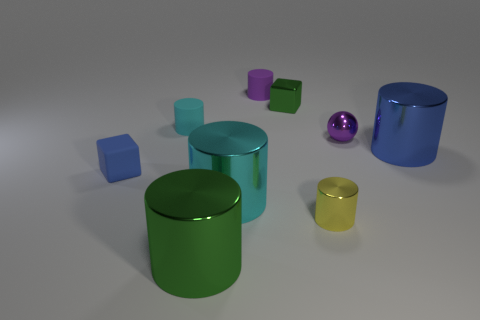The big metallic thing that is the same color as the tiny rubber block is what shape?
Provide a short and direct response. Cylinder. Is there a cylinder of the same color as the sphere?
Provide a succinct answer. Yes. What is the size of the shiny object that is the same color as the shiny block?
Give a very brief answer. Large. How many other things are the same color as the small matte block?
Make the answer very short. 1. The cyan metallic cylinder is what size?
Give a very brief answer. Large. Are there more metal things on the right side of the tiny metal ball than small green metal cubes in front of the large cyan cylinder?
Offer a terse response. Yes. What number of tiny cylinders are in front of the tiny block that is to the left of the green metal cylinder?
Make the answer very short. 1. There is a small green shiny thing that is behind the large cyan metal thing; is its shape the same as the blue rubber thing?
Your answer should be very brief. Yes. There is a green object that is the same shape as the large cyan object; what is it made of?
Provide a succinct answer. Metal. What number of cylinders are the same size as the blue rubber thing?
Give a very brief answer. 3. 